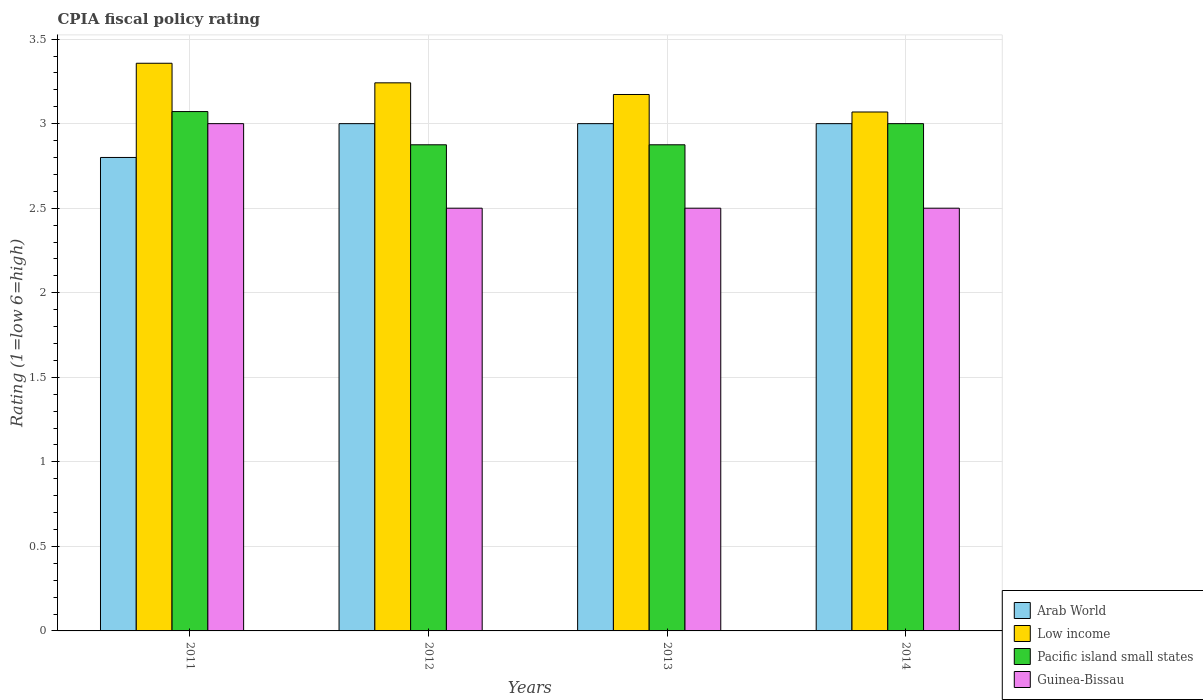Are the number of bars on each tick of the X-axis equal?
Provide a succinct answer. Yes. How many bars are there on the 2nd tick from the left?
Make the answer very short. 4. In how many cases, is the number of bars for a given year not equal to the number of legend labels?
Ensure brevity in your answer.  0. What is the CPIA rating in Low income in 2012?
Ensure brevity in your answer.  3.24. Across all years, what is the maximum CPIA rating in Pacific island small states?
Your response must be concise. 3.07. What is the total CPIA rating in Arab World in the graph?
Your answer should be very brief. 11.8. What is the difference between the CPIA rating in Arab World in 2011 and that in 2013?
Make the answer very short. -0.2. What is the difference between the CPIA rating in Arab World in 2011 and the CPIA rating in Low income in 2014?
Offer a terse response. -0.27. What is the average CPIA rating in Low income per year?
Your answer should be very brief. 3.21. In the year 2013, what is the difference between the CPIA rating in Pacific island small states and CPIA rating in Arab World?
Offer a very short reply. -0.12. Is the CPIA rating in Arab World in 2012 less than that in 2014?
Your response must be concise. No. Is the difference between the CPIA rating in Pacific island small states in 2012 and 2013 greater than the difference between the CPIA rating in Arab World in 2012 and 2013?
Your answer should be compact. No. What is the difference between the highest and the second highest CPIA rating in Pacific island small states?
Ensure brevity in your answer.  0.07. What is the difference between the highest and the lowest CPIA rating in Guinea-Bissau?
Offer a terse response. 0.5. In how many years, is the CPIA rating in Low income greater than the average CPIA rating in Low income taken over all years?
Your answer should be compact. 2. Is it the case that in every year, the sum of the CPIA rating in Guinea-Bissau and CPIA rating in Arab World is greater than the sum of CPIA rating in Low income and CPIA rating in Pacific island small states?
Provide a succinct answer. No. What does the 4th bar from the left in 2012 represents?
Your answer should be compact. Guinea-Bissau. What does the 4th bar from the right in 2011 represents?
Ensure brevity in your answer.  Arab World. Does the graph contain any zero values?
Your response must be concise. No. Does the graph contain grids?
Your answer should be compact. Yes. How are the legend labels stacked?
Make the answer very short. Vertical. What is the title of the graph?
Provide a succinct answer. CPIA fiscal policy rating. What is the Rating (1=low 6=high) of Arab World in 2011?
Offer a very short reply. 2.8. What is the Rating (1=low 6=high) in Low income in 2011?
Offer a very short reply. 3.36. What is the Rating (1=low 6=high) in Pacific island small states in 2011?
Provide a short and direct response. 3.07. What is the Rating (1=low 6=high) in Arab World in 2012?
Ensure brevity in your answer.  3. What is the Rating (1=low 6=high) in Low income in 2012?
Your answer should be compact. 3.24. What is the Rating (1=low 6=high) of Pacific island small states in 2012?
Ensure brevity in your answer.  2.88. What is the Rating (1=low 6=high) of Guinea-Bissau in 2012?
Offer a very short reply. 2.5. What is the Rating (1=low 6=high) of Arab World in 2013?
Your response must be concise. 3. What is the Rating (1=low 6=high) in Low income in 2013?
Your response must be concise. 3.17. What is the Rating (1=low 6=high) of Pacific island small states in 2013?
Provide a short and direct response. 2.88. What is the Rating (1=low 6=high) in Arab World in 2014?
Offer a terse response. 3. What is the Rating (1=low 6=high) of Low income in 2014?
Your answer should be very brief. 3.07. What is the Rating (1=low 6=high) of Guinea-Bissau in 2014?
Provide a succinct answer. 2.5. Across all years, what is the maximum Rating (1=low 6=high) in Low income?
Your answer should be compact. 3.36. Across all years, what is the maximum Rating (1=low 6=high) of Pacific island small states?
Provide a succinct answer. 3.07. Across all years, what is the maximum Rating (1=low 6=high) of Guinea-Bissau?
Your answer should be compact. 3. Across all years, what is the minimum Rating (1=low 6=high) in Low income?
Provide a succinct answer. 3.07. Across all years, what is the minimum Rating (1=low 6=high) of Pacific island small states?
Your answer should be very brief. 2.88. What is the total Rating (1=low 6=high) of Arab World in the graph?
Offer a very short reply. 11.8. What is the total Rating (1=low 6=high) of Low income in the graph?
Your response must be concise. 12.84. What is the total Rating (1=low 6=high) in Pacific island small states in the graph?
Provide a short and direct response. 11.82. What is the total Rating (1=low 6=high) in Guinea-Bissau in the graph?
Your answer should be very brief. 10.5. What is the difference between the Rating (1=low 6=high) in Low income in 2011 and that in 2012?
Give a very brief answer. 0.12. What is the difference between the Rating (1=low 6=high) of Pacific island small states in 2011 and that in 2012?
Offer a terse response. 0.2. What is the difference between the Rating (1=low 6=high) in Arab World in 2011 and that in 2013?
Ensure brevity in your answer.  -0.2. What is the difference between the Rating (1=low 6=high) of Low income in 2011 and that in 2013?
Provide a short and direct response. 0.18. What is the difference between the Rating (1=low 6=high) of Pacific island small states in 2011 and that in 2013?
Give a very brief answer. 0.2. What is the difference between the Rating (1=low 6=high) in Low income in 2011 and that in 2014?
Offer a terse response. 0.29. What is the difference between the Rating (1=low 6=high) in Pacific island small states in 2011 and that in 2014?
Provide a short and direct response. 0.07. What is the difference between the Rating (1=low 6=high) in Guinea-Bissau in 2011 and that in 2014?
Give a very brief answer. 0.5. What is the difference between the Rating (1=low 6=high) of Arab World in 2012 and that in 2013?
Keep it short and to the point. 0. What is the difference between the Rating (1=low 6=high) in Low income in 2012 and that in 2013?
Offer a terse response. 0.07. What is the difference between the Rating (1=low 6=high) of Low income in 2012 and that in 2014?
Give a very brief answer. 0.17. What is the difference between the Rating (1=low 6=high) of Pacific island small states in 2012 and that in 2014?
Your answer should be compact. -0.12. What is the difference between the Rating (1=low 6=high) of Arab World in 2013 and that in 2014?
Make the answer very short. 0. What is the difference between the Rating (1=low 6=high) of Low income in 2013 and that in 2014?
Your answer should be very brief. 0.1. What is the difference between the Rating (1=low 6=high) in Pacific island small states in 2013 and that in 2014?
Give a very brief answer. -0.12. What is the difference between the Rating (1=low 6=high) in Arab World in 2011 and the Rating (1=low 6=high) in Low income in 2012?
Provide a succinct answer. -0.44. What is the difference between the Rating (1=low 6=high) in Arab World in 2011 and the Rating (1=low 6=high) in Pacific island small states in 2012?
Your answer should be compact. -0.07. What is the difference between the Rating (1=low 6=high) in Arab World in 2011 and the Rating (1=low 6=high) in Guinea-Bissau in 2012?
Your answer should be very brief. 0.3. What is the difference between the Rating (1=low 6=high) of Low income in 2011 and the Rating (1=low 6=high) of Pacific island small states in 2012?
Your answer should be very brief. 0.48. What is the difference between the Rating (1=low 6=high) in Pacific island small states in 2011 and the Rating (1=low 6=high) in Guinea-Bissau in 2012?
Offer a very short reply. 0.57. What is the difference between the Rating (1=low 6=high) of Arab World in 2011 and the Rating (1=low 6=high) of Low income in 2013?
Your answer should be very brief. -0.37. What is the difference between the Rating (1=low 6=high) in Arab World in 2011 and the Rating (1=low 6=high) in Pacific island small states in 2013?
Ensure brevity in your answer.  -0.07. What is the difference between the Rating (1=low 6=high) of Arab World in 2011 and the Rating (1=low 6=high) of Guinea-Bissau in 2013?
Make the answer very short. 0.3. What is the difference between the Rating (1=low 6=high) of Low income in 2011 and the Rating (1=low 6=high) of Pacific island small states in 2013?
Offer a terse response. 0.48. What is the difference between the Rating (1=low 6=high) of Arab World in 2011 and the Rating (1=low 6=high) of Low income in 2014?
Your answer should be very brief. -0.27. What is the difference between the Rating (1=low 6=high) in Low income in 2011 and the Rating (1=low 6=high) in Pacific island small states in 2014?
Provide a short and direct response. 0.36. What is the difference between the Rating (1=low 6=high) of Low income in 2011 and the Rating (1=low 6=high) of Guinea-Bissau in 2014?
Your answer should be compact. 0.86. What is the difference between the Rating (1=low 6=high) of Arab World in 2012 and the Rating (1=low 6=high) of Low income in 2013?
Provide a short and direct response. -0.17. What is the difference between the Rating (1=low 6=high) of Arab World in 2012 and the Rating (1=low 6=high) of Guinea-Bissau in 2013?
Give a very brief answer. 0.5. What is the difference between the Rating (1=low 6=high) in Low income in 2012 and the Rating (1=low 6=high) in Pacific island small states in 2013?
Provide a succinct answer. 0.37. What is the difference between the Rating (1=low 6=high) in Low income in 2012 and the Rating (1=low 6=high) in Guinea-Bissau in 2013?
Provide a succinct answer. 0.74. What is the difference between the Rating (1=low 6=high) in Pacific island small states in 2012 and the Rating (1=low 6=high) in Guinea-Bissau in 2013?
Provide a succinct answer. 0.38. What is the difference between the Rating (1=low 6=high) in Arab World in 2012 and the Rating (1=low 6=high) in Low income in 2014?
Your answer should be very brief. -0.07. What is the difference between the Rating (1=low 6=high) in Arab World in 2012 and the Rating (1=low 6=high) in Pacific island small states in 2014?
Provide a succinct answer. 0. What is the difference between the Rating (1=low 6=high) of Arab World in 2012 and the Rating (1=low 6=high) of Guinea-Bissau in 2014?
Your answer should be very brief. 0.5. What is the difference between the Rating (1=low 6=high) of Low income in 2012 and the Rating (1=low 6=high) of Pacific island small states in 2014?
Your answer should be very brief. 0.24. What is the difference between the Rating (1=low 6=high) in Low income in 2012 and the Rating (1=low 6=high) in Guinea-Bissau in 2014?
Make the answer very short. 0.74. What is the difference between the Rating (1=low 6=high) of Arab World in 2013 and the Rating (1=low 6=high) of Low income in 2014?
Make the answer very short. -0.07. What is the difference between the Rating (1=low 6=high) in Arab World in 2013 and the Rating (1=low 6=high) in Guinea-Bissau in 2014?
Provide a succinct answer. 0.5. What is the difference between the Rating (1=low 6=high) in Low income in 2013 and the Rating (1=low 6=high) in Pacific island small states in 2014?
Offer a very short reply. 0.17. What is the difference between the Rating (1=low 6=high) in Low income in 2013 and the Rating (1=low 6=high) in Guinea-Bissau in 2014?
Your response must be concise. 0.67. What is the difference between the Rating (1=low 6=high) of Pacific island small states in 2013 and the Rating (1=low 6=high) of Guinea-Bissau in 2014?
Your response must be concise. 0.38. What is the average Rating (1=low 6=high) of Arab World per year?
Keep it short and to the point. 2.95. What is the average Rating (1=low 6=high) of Low income per year?
Offer a very short reply. 3.21. What is the average Rating (1=low 6=high) in Pacific island small states per year?
Provide a succinct answer. 2.96. What is the average Rating (1=low 6=high) of Guinea-Bissau per year?
Ensure brevity in your answer.  2.62. In the year 2011, what is the difference between the Rating (1=low 6=high) in Arab World and Rating (1=low 6=high) in Low income?
Offer a very short reply. -0.56. In the year 2011, what is the difference between the Rating (1=low 6=high) in Arab World and Rating (1=low 6=high) in Pacific island small states?
Your response must be concise. -0.27. In the year 2011, what is the difference between the Rating (1=low 6=high) of Low income and Rating (1=low 6=high) of Pacific island small states?
Make the answer very short. 0.29. In the year 2011, what is the difference between the Rating (1=low 6=high) of Low income and Rating (1=low 6=high) of Guinea-Bissau?
Provide a succinct answer. 0.36. In the year 2011, what is the difference between the Rating (1=low 6=high) in Pacific island small states and Rating (1=low 6=high) in Guinea-Bissau?
Give a very brief answer. 0.07. In the year 2012, what is the difference between the Rating (1=low 6=high) of Arab World and Rating (1=low 6=high) of Low income?
Give a very brief answer. -0.24. In the year 2012, what is the difference between the Rating (1=low 6=high) in Arab World and Rating (1=low 6=high) in Pacific island small states?
Offer a very short reply. 0.12. In the year 2012, what is the difference between the Rating (1=low 6=high) of Low income and Rating (1=low 6=high) of Pacific island small states?
Offer a very short reply. 0.37. In the year 2012, what is the difference between the Rating (1=low 6=high) of Low income and Rating (1=low 6=high) of Guinea-Bissau?
Give a very brief answer. 0.74. In the year 2012, what is the difference between the Rating (1=low 6=high) in Pacific island small states and Rating (1=low 6=high) in Guinea-Bissau?
Your answer should be very brief. 0.38. In the year 2013, what is the difference between the Rating (1=low 6=high) of Arab World and Rating (1=low 6=high) of Low income?
Give a very brief answer. -0.17. In the year 2013, what is the difference between the Rating (1=low 6=high) in Arab World and Rating (1=low 6=high) in Pacific island small states?
Your response must be concise. 0.12. In the year 2013, what is the difference between the Rating (1=low 6=high) in Low income and Rating (1=low 6=high) in Pacific island small states?
Provide a short and direct response. 0.3. In the year 2013, what is the difference between the Rating (1=low 6=high) of Low income and Rating (1=low 6=high) of Guinea-Bissau?
Make the answer very short. 0.67. In the year 2013, what is the difference between the Rating (1=low 6=high) in Pacific island small states and Rating (1=low 6=high) in Guinea-Bissau?
Offer a terse response. 0.38. In the year 2014, what is the difference between the Rating (1=low 6=high) in Arab World and Rating (1=low 6=high) in Low income?
Give a very brief answer. -0.07. In the year 2014, what is the difference between the Rating (1=low 6=high) in Arab World and Rating (1=low 6=high) in Guinea-Bissau?
Keep it short and to the point. 0.5. In the year 2014, what is the difference between the Rating (1=low 6=high) of Low income and Rating (1=low 6=high) of Pacific island small states?
Keep it short and to the point. 0.07. In the year 2014, what is the difference between the Rating (1=low 6=high) of Low income and Rating (1=low 6=high) of Guinea-Bissau?
Your response must be concise. 0.57. In the year 2014, what is the difference between the Rating (1=low 6=high) of Pacific island small states and Rating (1=low 6=high) of Guinea-Bissau?
Offer a very short reply. 0.5. What is the ratio of the Rating (1=low 6=high) in Arab World in 2011 to that in 2012?
Provide a succinct answer. 0.93. What is the ratio of the Rating (1=low 6=high) in Low income in 2011 to that in 2012?
Offer a very short reply. 1.04. What is the ratio of the Rating (1=low 6=high) in Pacific island small states in 2011 to that in 2012?
Offer a very short reply. 1.07. What is the ratio of the Rating (1=low 6=high) in Arab World in 2011 to that in 2013?
Ensure brevity in your answer.  0.93. What is the ratio of the Rating (1=low 6=high) of Low income in 2011 to that in 2013?
Offer a terse response. 1.06. What is the ratio of the Rating (1=low 6=high) in Pacific island small states in 2011 to that in 2013?
Make the answer very short. 1.07. What is the ratio of the Rating (1=low 6=high) of Guinea-Bissau in 2011 to that in 2013?
Offer a terse response. 1.2. What is the ratio of the Rating (1=low 6=high) of Low income in 2011 to that in 2014?
Give a very brief answer. 1.09. What is the ratio of the Rating (1=low 6=high) of Pacific island small states in 2011 to that in 2014?
Your response must be concise. 1.02. What is the ratio of the Rating (1=low 6=high) of Guinea-Bissau in 2011 to that in 2014?
Offer a terse response. 1.2. What is the ratio of the Rating (1=low 6=high) in Low income in 2012 to that in 2013?
Offer a very short reply. 1.02. What is the ratio of the Rating (1=low 6=high) of Arab World in 2012 to that in 2014?
Give a very brief answer. 1. What is the ratio of the Rating (1=low 6=high) in Low income in 2012 to that in 2014?
Your response must be concise. 1.06. What is the ratio of the Rating (1=low 6=high) in Low income in 2013 to that in 2014?
Provide a succinct answer. 1.03. What is the ratio of the Rating (1=low 6=high) of Pacific island small states in 2013 to that in 2014?
Keep it short and to the point. 0.96. What is the difference between the highest and the second highest Rating (1=low 6=high) of Low income?
Provide a short and direct response. 0.12. What is the difference between the highest and the second highest Rating (1=low 6=high) of Pacific island small states?
Offer a very short reply. 0.07. What is the difference between the highest and the second highest Rating (1=low 6=high) in Guinea-Bissau?
Ensure brevity in your answer.  0.5. What is the difference between the highest and the lowest Rating (1=low 6=high) of Low income?
Make the answer very short. 0.29. What is the difference between the highest and the lowest Rating (1=low 6=high) of Pacific island small states?
Provide a succinct answer. 0.2. 